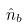Convert formula to latex. <formula><loc_0><loc_0><loc_500><loc_500>\hat { n } _ { b }</formula> 